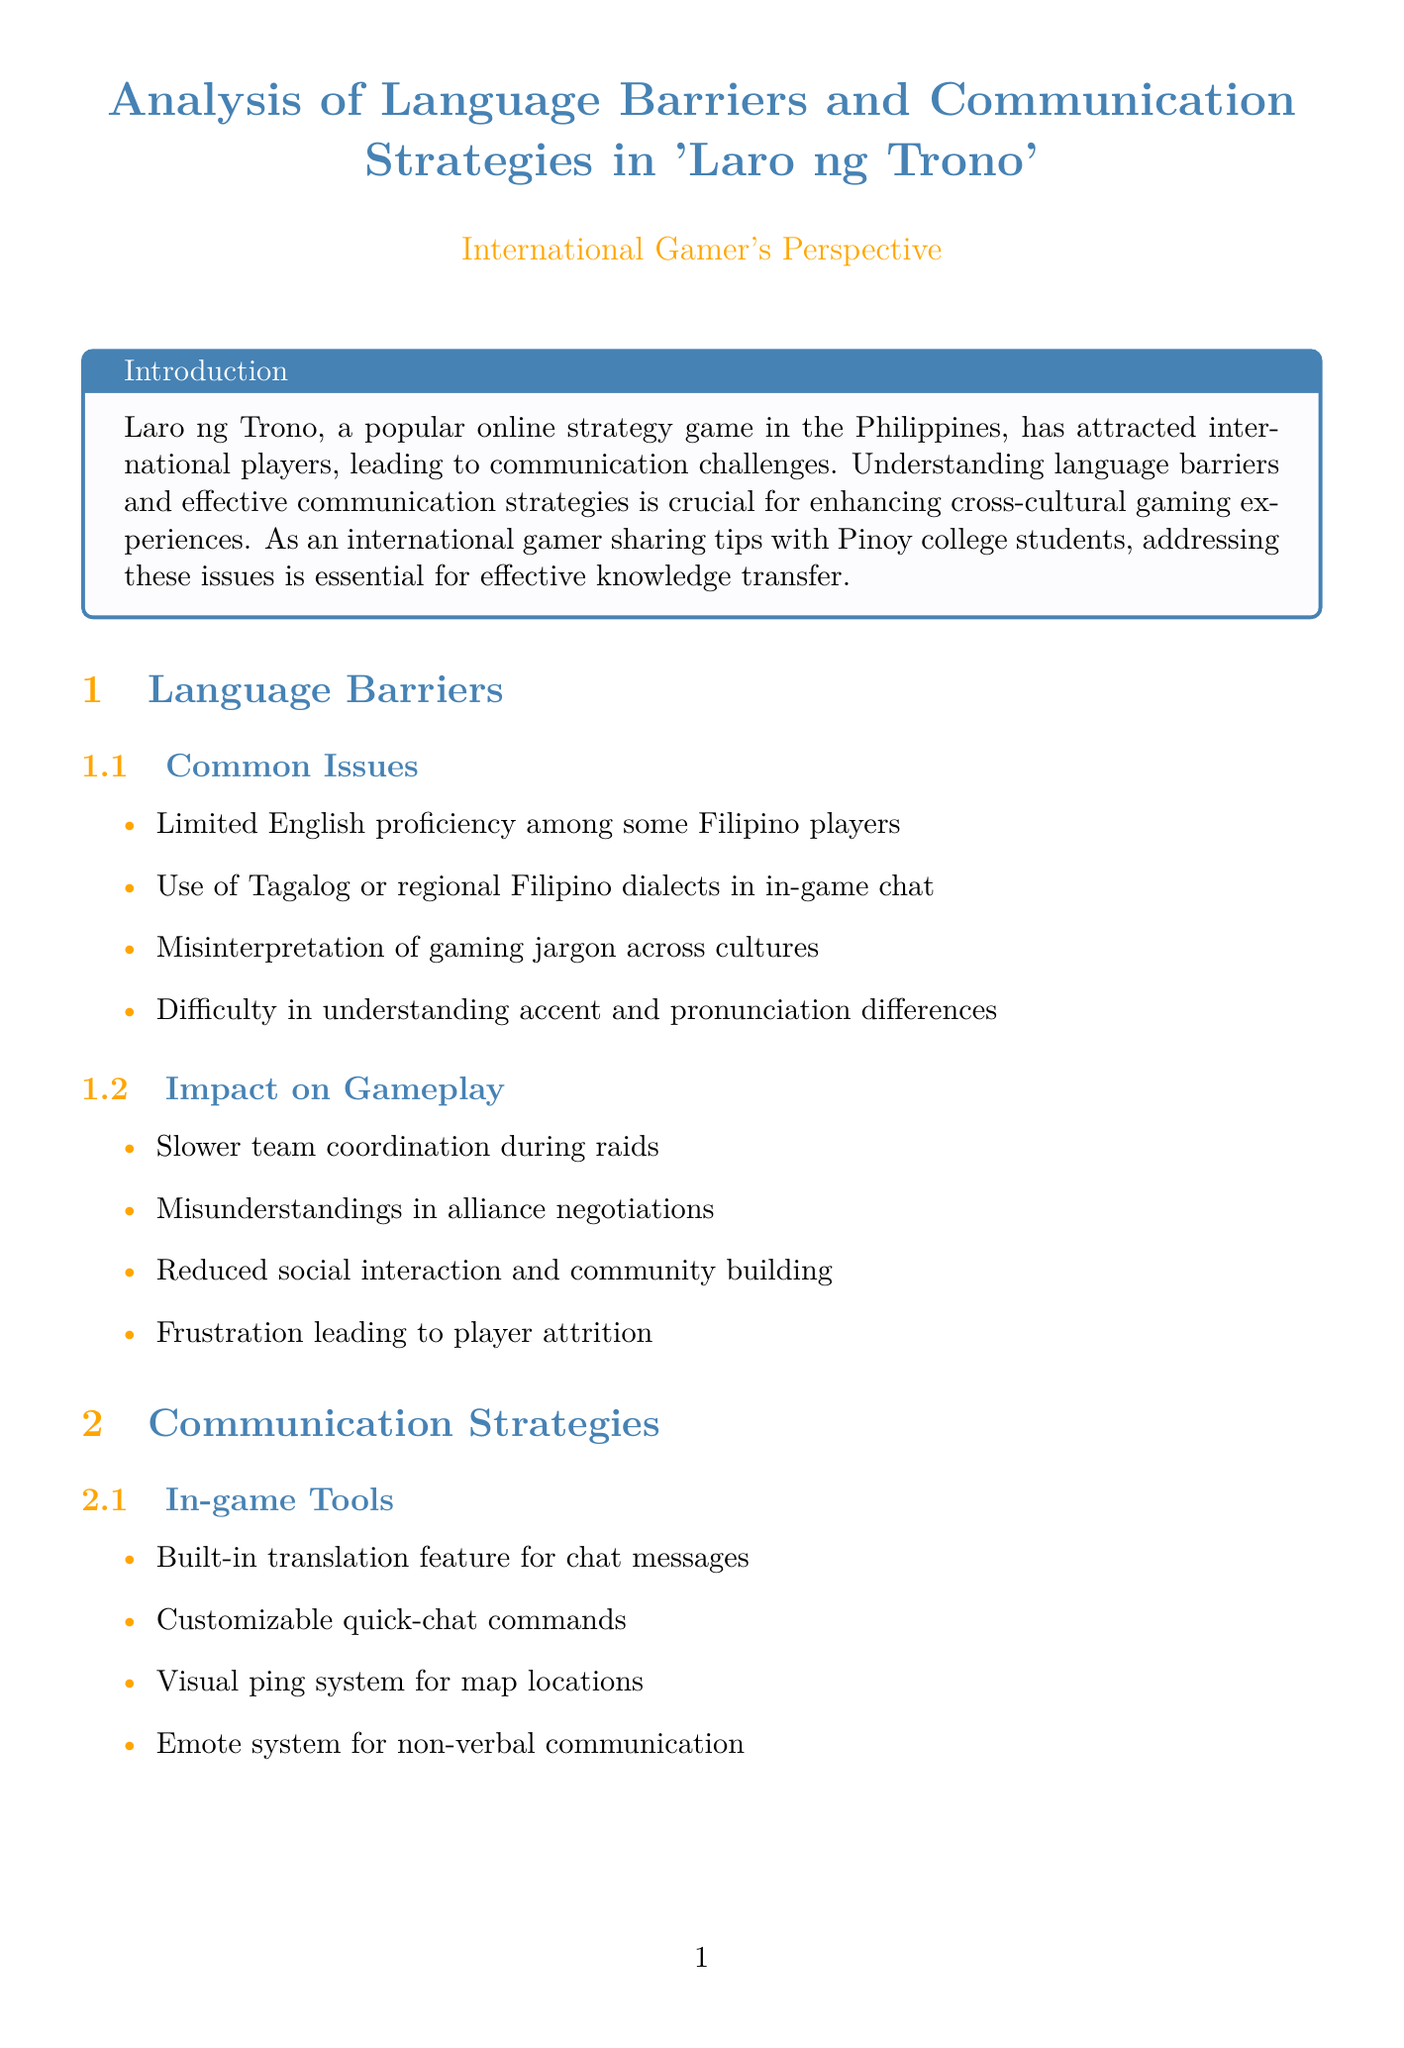What is the main focus of the report? The report focuses on analyzing language barriers and communication strategies in Laro ng Trono to improve cross-cultural gaming experiences.
Answer: Language barriers and communication strategies Who is the success story player mentioned in the report? The report highlights Sarah Johnson as a player who successfully integrated by learning Tagalog and creating bilingual guides.
Answer: Sarah Johnson What common issue is faced by some Filipino players? The report states that limited English proficiency is a common issue encountered by some Filipino players.
Answer: Limited English proficiency What is one of the recommendations for game developers? One recommendation is to implement more sophisticated in-game translation tools to address communication issues.
Answer: More sophisticated in-game translation tools Which player faced challenges with Filipino gaming slang? Hiroshi Tanaka is mentioned as a player who faced difficulties understanding Filipino gaming slang.
Answer: Hiroshi Tanaka How can players improve communication according to the report? The report suggests that players should invest time in learning basic phrases in other languages for better communication.
Answer: Learning basic phrases in other languages What impact do language barriers have on gameplay? Language barriers can lead to slower team coordination during raids as noted in the report.
Answer: Slower team coordination during raids What type of community effort is mentioned in the report? The report discusses international guilds with a language learning focus as a community effort to bridge language gaps.
Answer: International guilds with language learning focus 